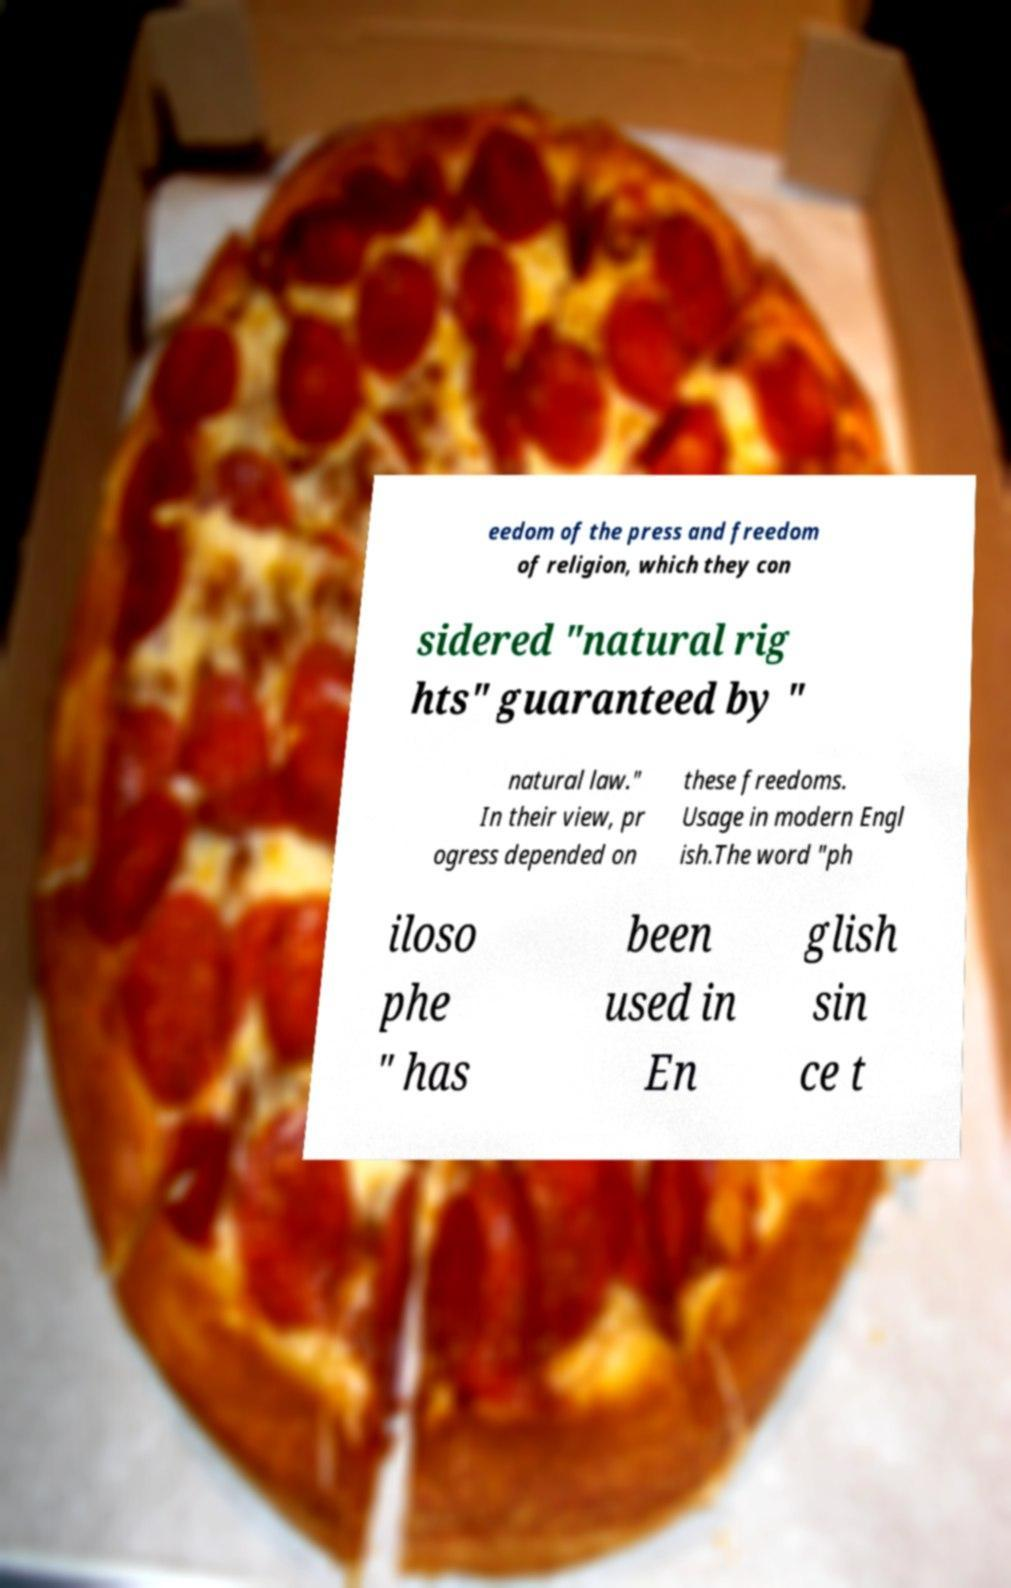Could you extract and type out the text from this image? eedom of the press and freedom of religion, which they con sidered "natural rig hts" guaranteed by " natural law." In their view, pr ogress depended on these freedoms. Usage in modern Engl ish.The word "ph iloso phe " has been used in En glish sin ce t 